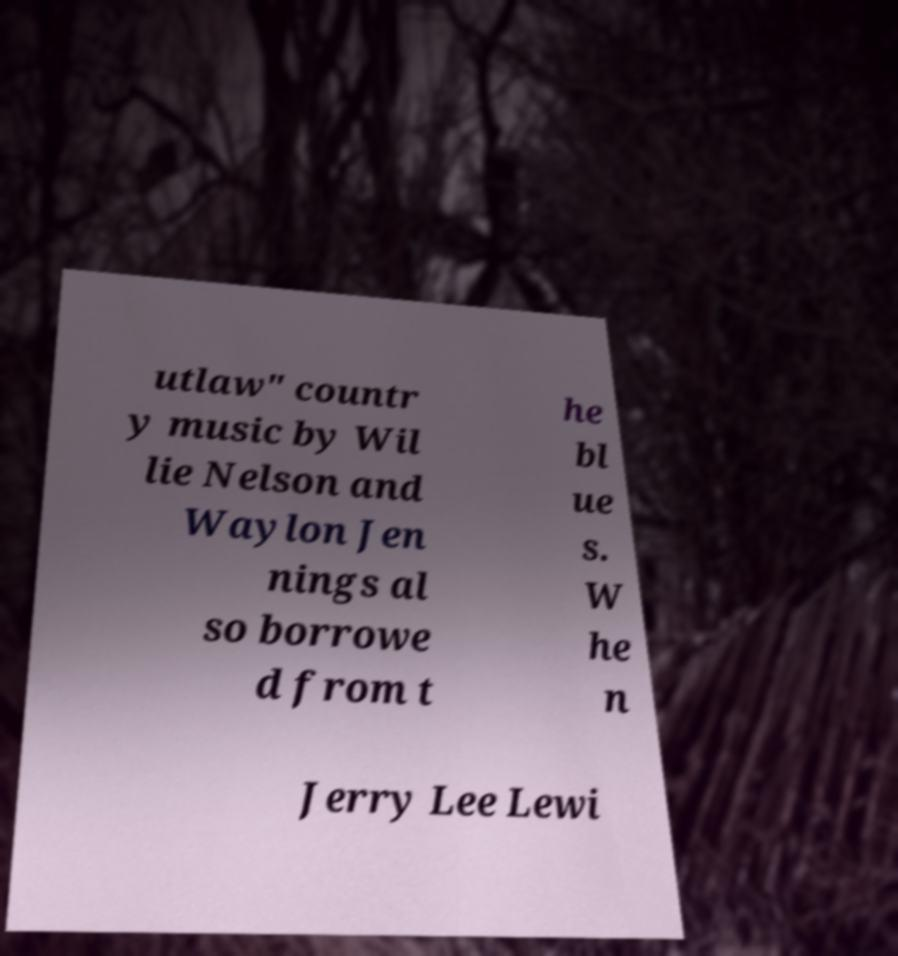For documentation purposes, I need the text within this image transcribed. Could you provide that? utlaw" countr y music by Wil lie Nelson and Waylon Jen nings al so borrowe d from t he bl ue s. W he n Jerry Lee Lewi 